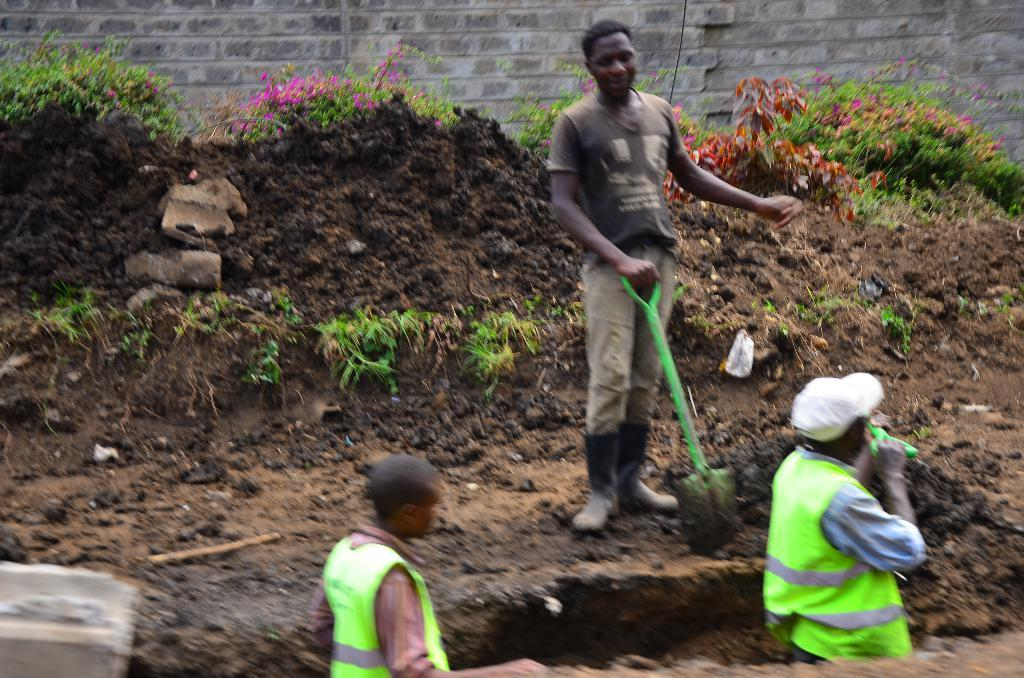How many people are in the foreground of the image? There are two people in the foreground of the image. What is the person in the middle of the image holding? The person in the middle of the image is holding a spade. What can be seen in the background of the image? There is a wall visible in the background of the image. What type of environment is depicted in the image? The image shows a garden or planting area, as there are many plants around. What language is the person holding the spade speaking in the image? There is no indication of the language being spoken in the image, as it does not contain any audio or text. 